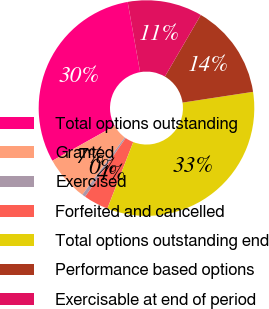Convert chart. <chart><loc_0><loc_0><loc_500><loc_500><pie_chart><fcel>Total options outstanding<fcel>Granted<fcel>Exercised<fcel>Forfeited and cancelled<fcel>Total options outstanding end<fcel>Performance based options<fcel>Exercisable at end of period<nl><fcel>30.33%<fcel>6.73%<fcel>0.5%<fcel>3.74%<fcel>33.32%<fcel>14.19%<fcel>11.2%<nl></chart> 